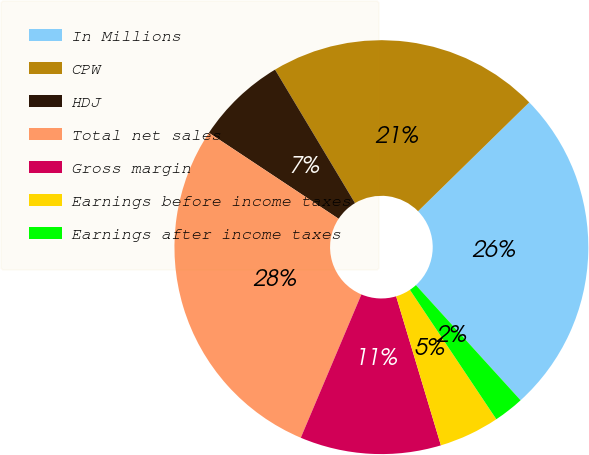Convert chart. <chart><loc_0><loc_0><loc_500><loc_500><pie_chart><fcel>In Millions<fcel>CPW<fcel>HDJ<fcel>Total net sales<fcel>Gross margin<fcel>Earnings before income taxes<fcel>Earnings after income taxes<nl><fcel>25.59%<fcel>21.26%<fcel>7.09%<fcel>27.95%<fcel>11.01%<fcel>4.73%<fcel>2.37%<nl></chart> 